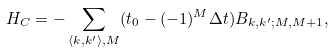<formula> <loc_0><loc_0><loc_500><loc_500>H _ { C } = - \sum _ { \langle k , k ^ { \prime } \rangle , M } ( t _ { 0 } - ( - 1 ) ^ { M } \Delta t ) B _ { k , k ^ { \prime } ; M , M + 1 } ,</formula> 